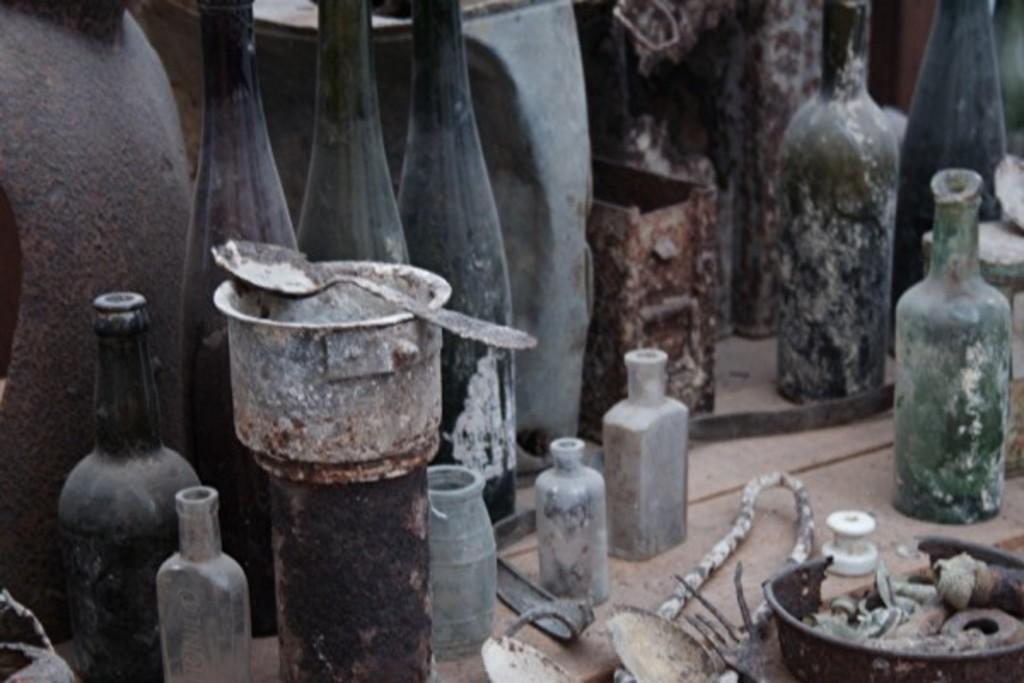What type of objects can be seen in the image? There are bottles and utensils in the image. Can you describe the bottles in the image? The provided facts do not give specific details about the bottles, so we cannot describe them further. What type of utensils are present in the image? The provided facts do not give specific details about the utensils, so we cannot describe them further. What type of calculator can be seen on the table in the image? There is no calculator present in the image; it only contains bottles and utensils. 